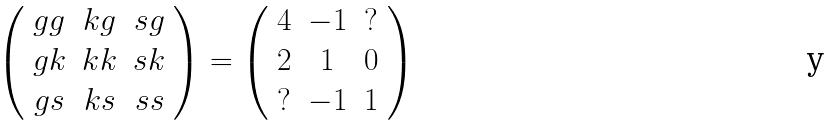Convert formula to latex. <formula><loc_0><loc_0><loc_500><loc_500>\left ( \begin{array} { c c c } g g & k g & s g \\ g k & k k & s k \\ g s & k s & s s \end{array} \right ) = \left ( \begin{array} { c c c } 4 & - 1 & ? \\ 2 & 1 & 0 \\ ? & - 1 & 1 \end{array} \right )</formula> 